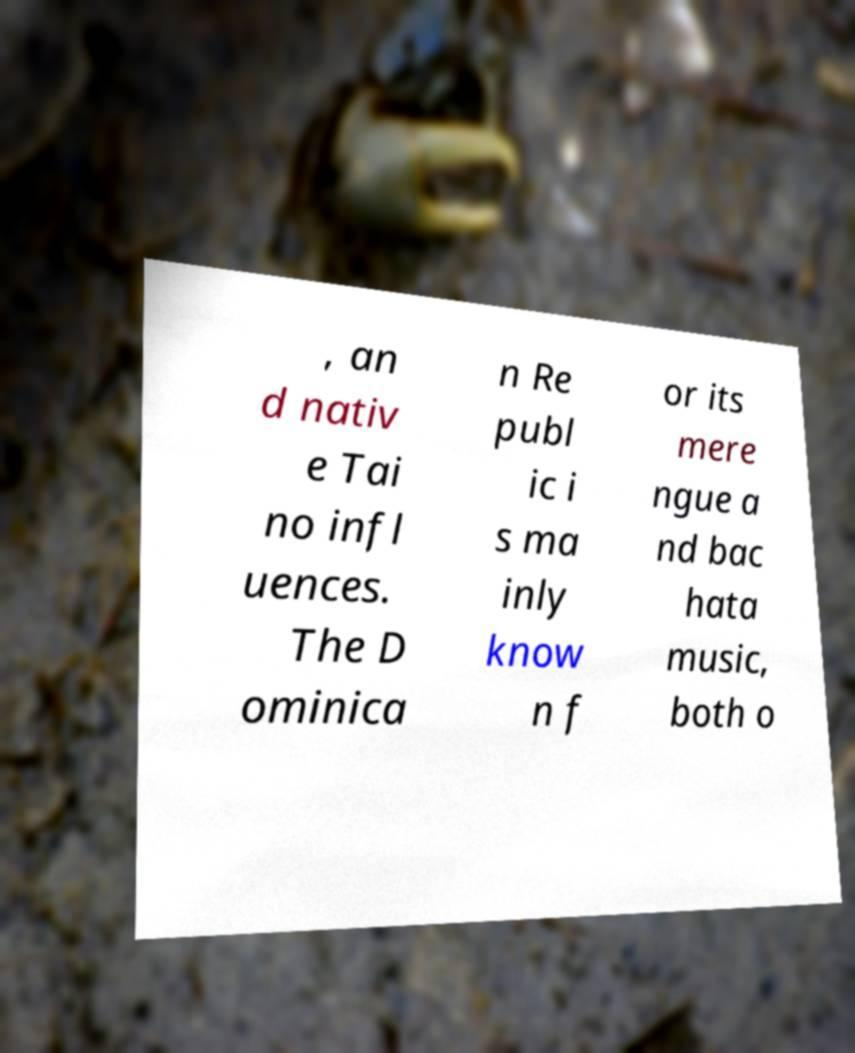Please identify and transcribe the text found in this image. , an d nativ e Tai no infl uences. The D ominica n Re publ ic i s ma inly know n f or its mere ngue a nd bac hata music, both o 